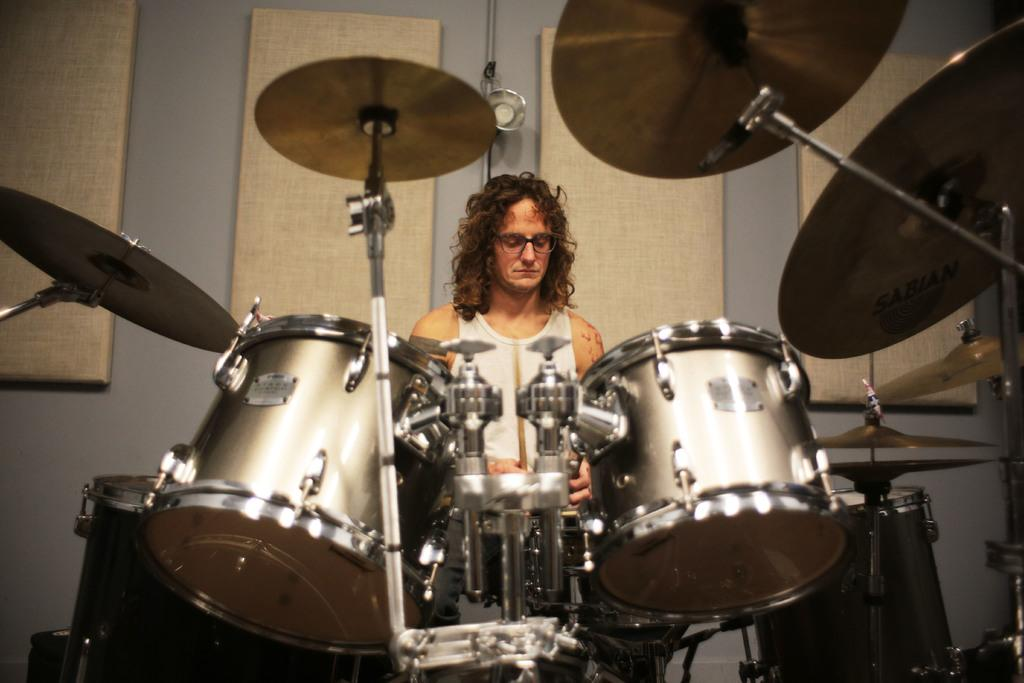What can be seen in the background of the image? There is a wall in the image. Who is present in the image? There is a person in the image. What is the person wearing? The person is wearing spectacles and a white dress. What is the person doing in the image? The person is playing musical instruments. What type of insurance policy does the person have in the image? There is no information about insurance policies in the image; it only shows a person playing musical instruments. 